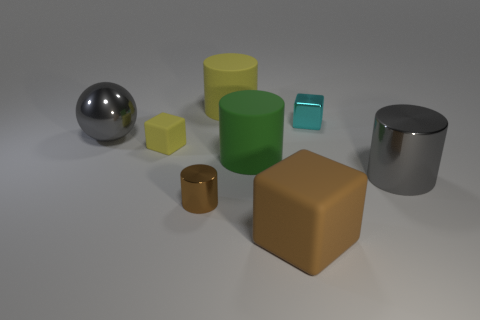Add 2 green metallic cylinders. How many objects exist? 10 Subtract all cubes. How many objects are left? 5 Add 8 yellow rubber objects. How many yellow rubber objects are left? 10 Add 5 big brown cubes. How many big brown cubes exist? 6 Subtract 1 brown blocks. How many objects are left? 7 Subtract all tiny green objects. Subtract all tiny yellow cubes. How many objects are left? 7 